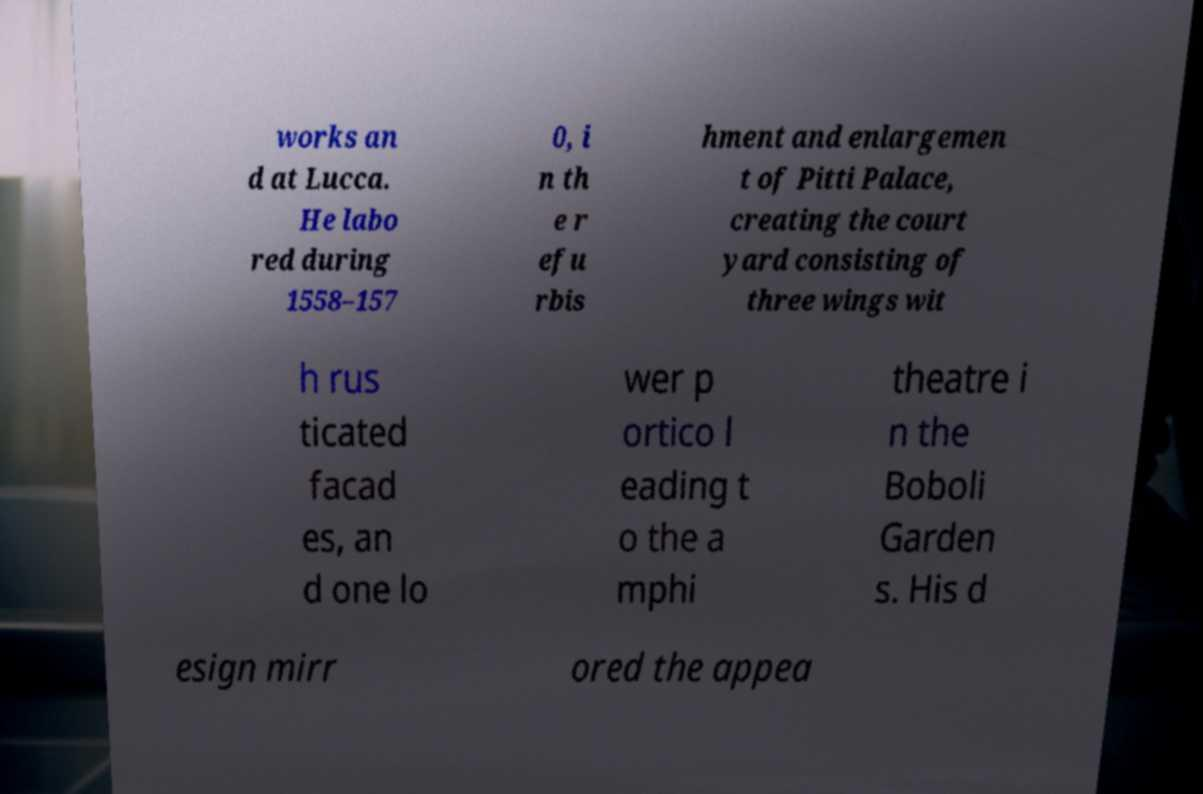Please identify and transcribe the text found in this image. works an d at Lucca. He labo red during 1558–157 0, i n th e r efu rbis hment and enlargemen t of Pitti Palace, creating the court yard consisting of three wings wit h rus ticated facad es, an d one lo wer p ortico l eading t o the a mphi theatre i n the Boboli Garden s. His d esign mirr ored the appea 